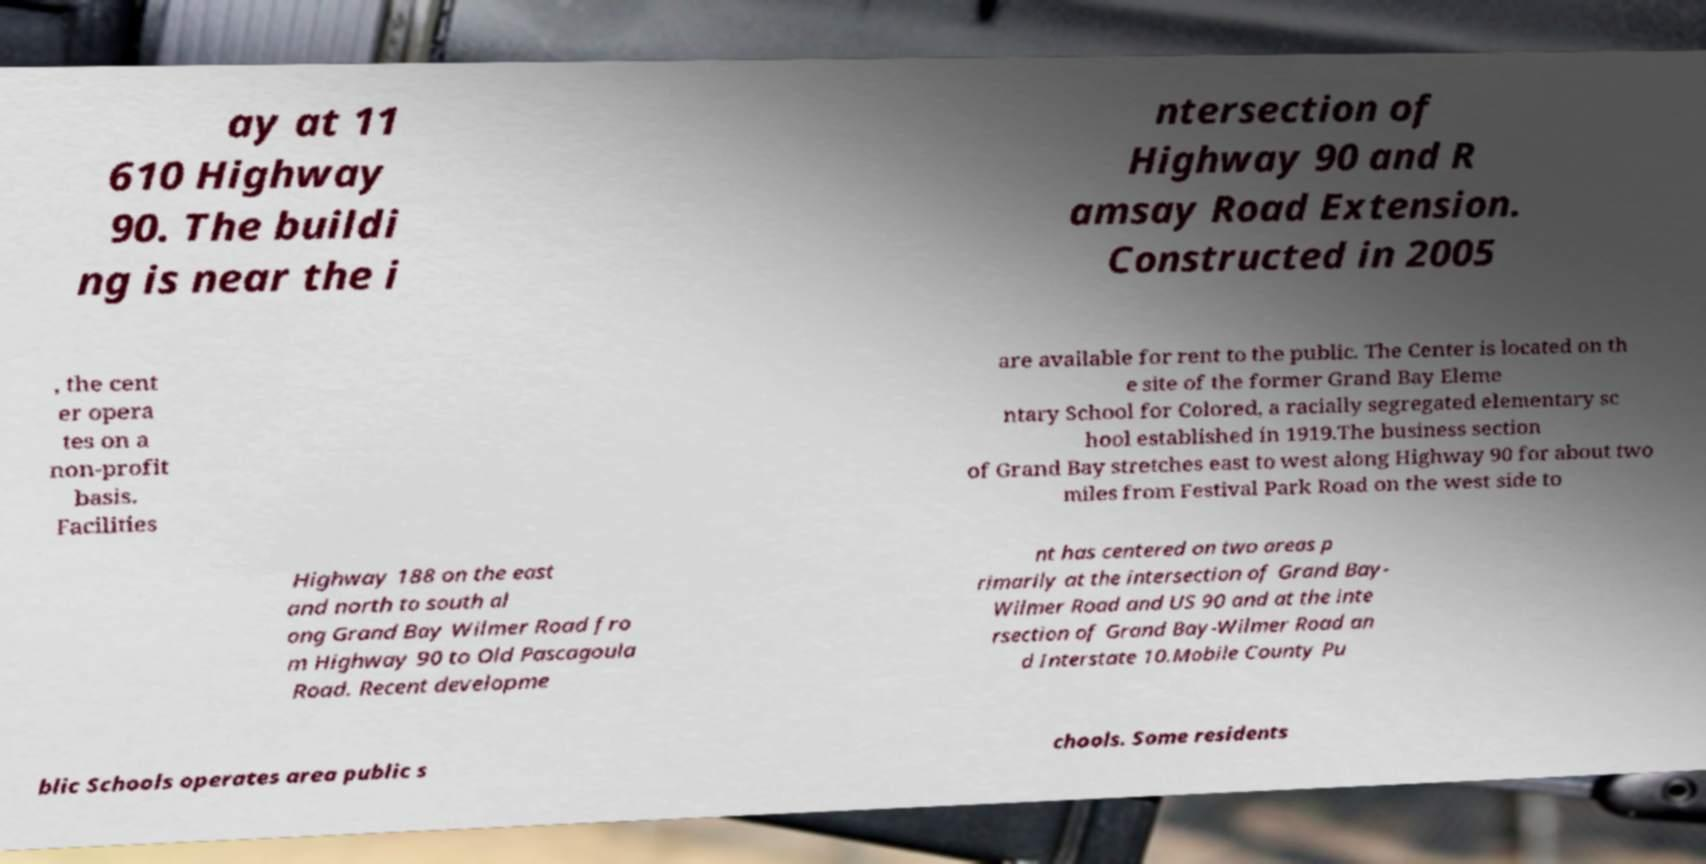Could you extract and type out the text from this image? ay at 11 610 Highway 90. The buildi ng is near the i ntersection of Highway 90 and R amsay Road Extension. Constructed in 2005 , the cent er opera tes on a non-profit basis. Facilities are available for rent to the public. The Center is located on th e site of the former Grand Bay Eleme ntary School for Colored, a racially segregated elementary sc hool established in 1919.The business section of Grand Bay stretches east to west along Highway 90 for about two miles from Festival Park Road on the west side to Highway 188 on the east and north to south al ong Grand Bay Wilmer Road fro m Highway 90 to Old Pascagoula Road. Recent developme nt has centered on two areas p rimarily at the intersection of Grand Bay- Wilmer Road and US 90 and at the inte rsection of Grand Bay-Wilmer Road an d Interstate 10.Mobile County Pu blic Schools operates area public s chools. Some residents 